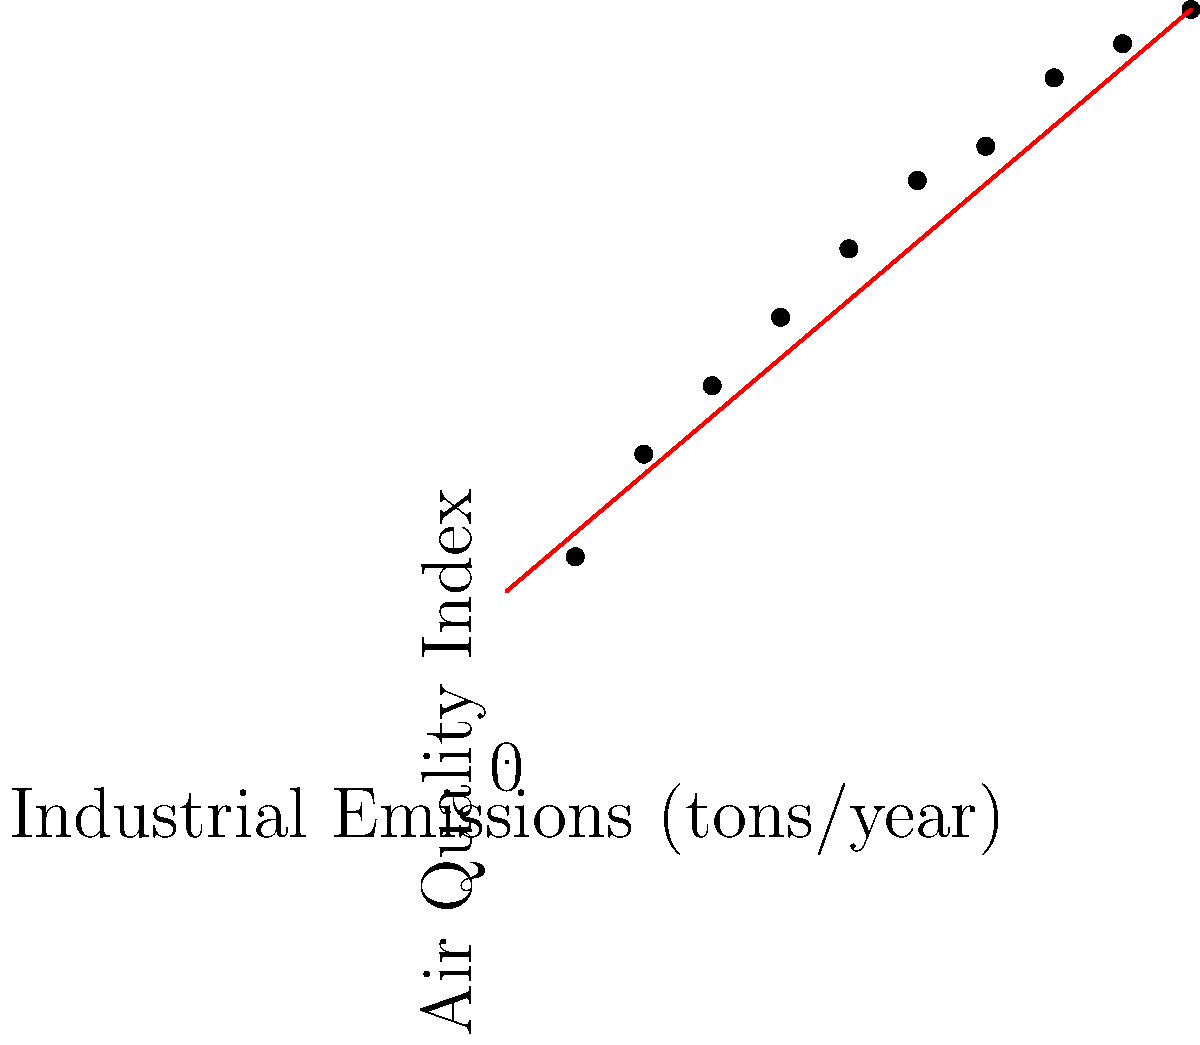Based on the scatter plot showing the relationship between industrial emissions and air quality index, what policy recommendation would you make to improve air quality in urban areas? To answer this question, we need to analyze the scatter plot and understand its implications:

1. Observe the trend: The scatter plot shows a clear positive correlation between industrial emissions and air quality index. As emissions increase, the air quality index also increases (higher index indicates worse air quality).

2. Assess the relationship: The red line represents the best-fit line, indicating a strong linear relationship between the two variables.

3. Quantify the impact: For every 10-unit increase in industrial emissions, there's approximately an 8.5-unit increase in the air quality index (based on the slope of the best-fit line).

4. Consider policy implications: 
   a) Reducing industrial emissions would likely lead to improved air quality.
   b) Stricter regulations on industrial emissions could be an effective way to address air quality issues.
   c) Incentives for industries to adopt cleaner technologies could help mitigate the problem.

5. Formulate a recommendation: Given the strong correlation, a policy focusing on reducing industrial emissions through a combination of regulations and incentives would be most effective in improving urban air quality.
Answer: Implement stricter industrial emission regulations and provide incentives for clean technology adoption. 